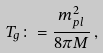<formula> <loc_0><loc_0><loc_500><loc_500>T _ { g } \colon = \frac { m _ { p l } ^ { 2 } } { 8 \pi M } \, ,</formula> 